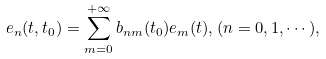Convert formula to latex. <formula><loc_0><loc_0><loc_500><loc_500>e _ { n } ( t , t _ { 0 } ) = \sum _ { m = 0 } ^ { + \infty } b _ { n m } ( t _ { 0 } ) e _ { m } ( t ) , ( n = 0 , 1 , \cdots ) ,</formula> 